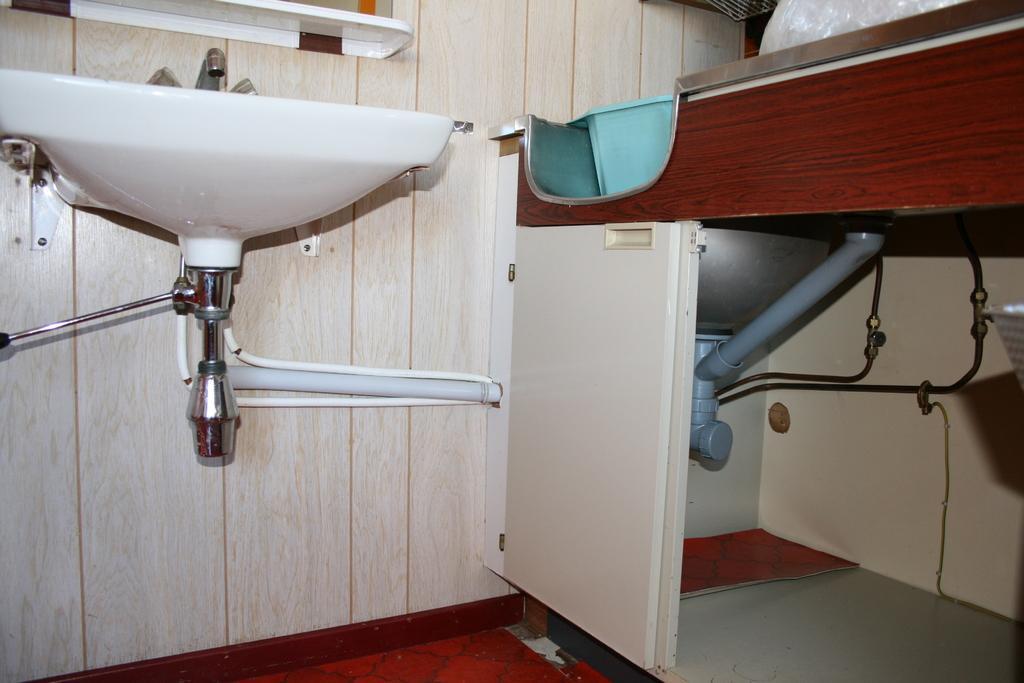How would you summarize this image in a sentence or two? In this image we can see wash basin, tap, wooden cupboard where we can see pipes, wooden door and floor. Here we can see the mirror. 